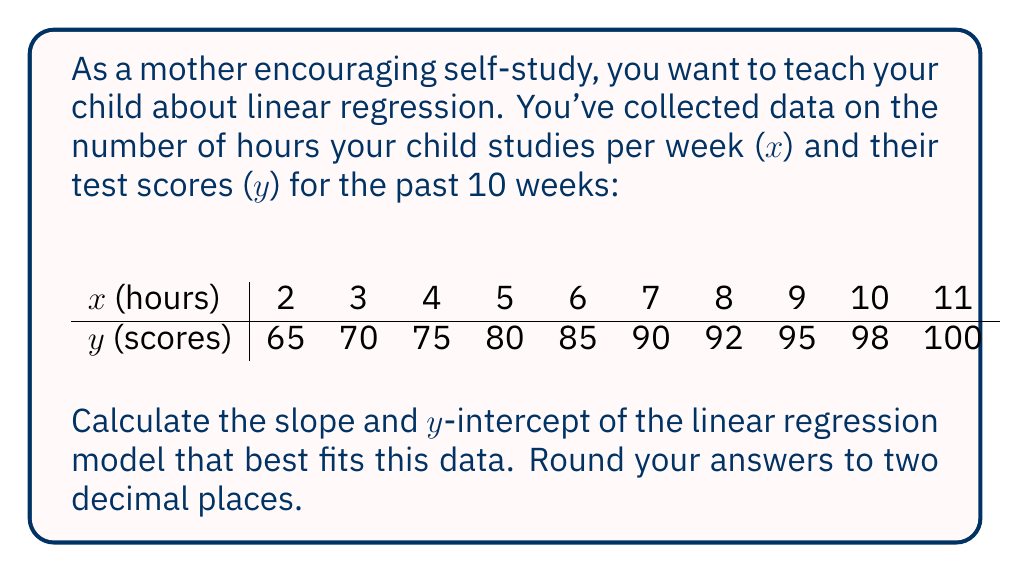What is the answer to this math problem? To calculate the slope and y-intercept of a linear regression model, we'll use the following formulas:

Slope (m): $$ m = \frac{n\sum{xy} - \sum{x}\sum{y}}{n\sum{x^2} - (\sum{x})^2} $$

Y-intercept (b): $$ b = \frac{\sum{y} - m\sum{x}}{n} $$

Where n is the number of data points.

Step 1: Calculate the required sums:
n = 10
$\sum{x} = 65$
$\sum{y} = 850$
$\sum{xy} = 6,025$
$\sum{x^2} = 505$

Step 2: Calculate the slope (m):

$$ m = \frac{10(6,025) - 65(850)}{10(505) - 65^2} $$
$$ m = \frac{60,250 - 55,250}{5,050 - 4,225} $$
$$ m = \frac{5,000}{825} $$
$$ m \approx 6.06 $$

Step 3: Calculate the y-intercept (b):

$$ b = \frac{850 - 6.06(65)}{10} $$
$$ b = \frac{850 - 393.90}{10} $$
$$ b = \frac{456.10}{10} $$
$$ b \approx 45.61 $$

Therefore, the linear regression equation is:
$$ y = 6.06x + 45.61 $$
Answer: Slope (m) ≈ 6.06
Y-intercept (b) ≈ 45.61 